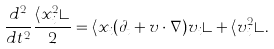Convert formula to latex. <formula><loc_0><loc_0><loc_500><loc_500>\frac { d ^ { 2 } } { d t ^ { 2 } } \frac { \langle x _ { i } ^ { 2 } \rangle } { 2 } = \langle x _ { i } ( \partial _ { t } + { v } \cdot \nabla ) v _ { i } \rangle + \langle v _ { i } ^ { 2 } \rangle .</formula> 